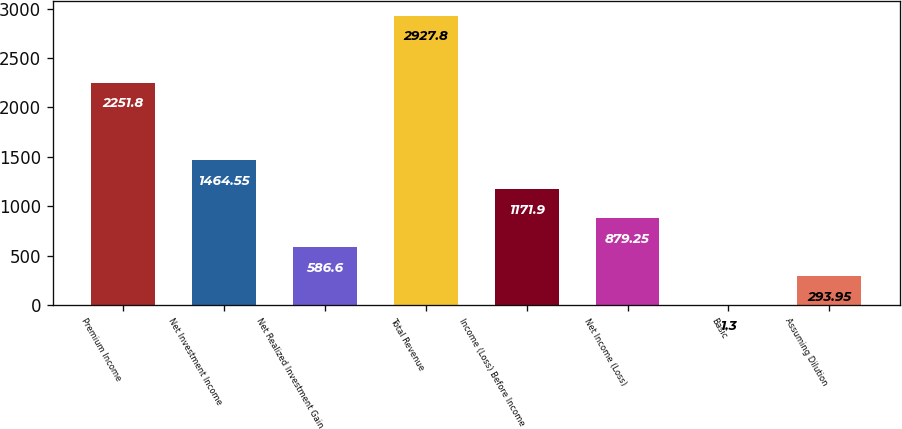Convert chart. <chart><loc_0><loc_0><loc_500><loc_500><bar_chart><fcel>Premium Income<fcel>Net Investment Income<fcel>Net Realized Investment Gain<fcel>Total Revenue<fcel>Income (Loss) Before Income<fcel>Net Income (Loss)<fcel>Basic<fcel>Assuming Dilution<nl><fcel>2251.8<fcel>1464.55<fcel>586.6<fcel>2927.8<fcel>1171.9<fcel>879.25<fcel>1.3<fcel>293.95<nl></chart> 